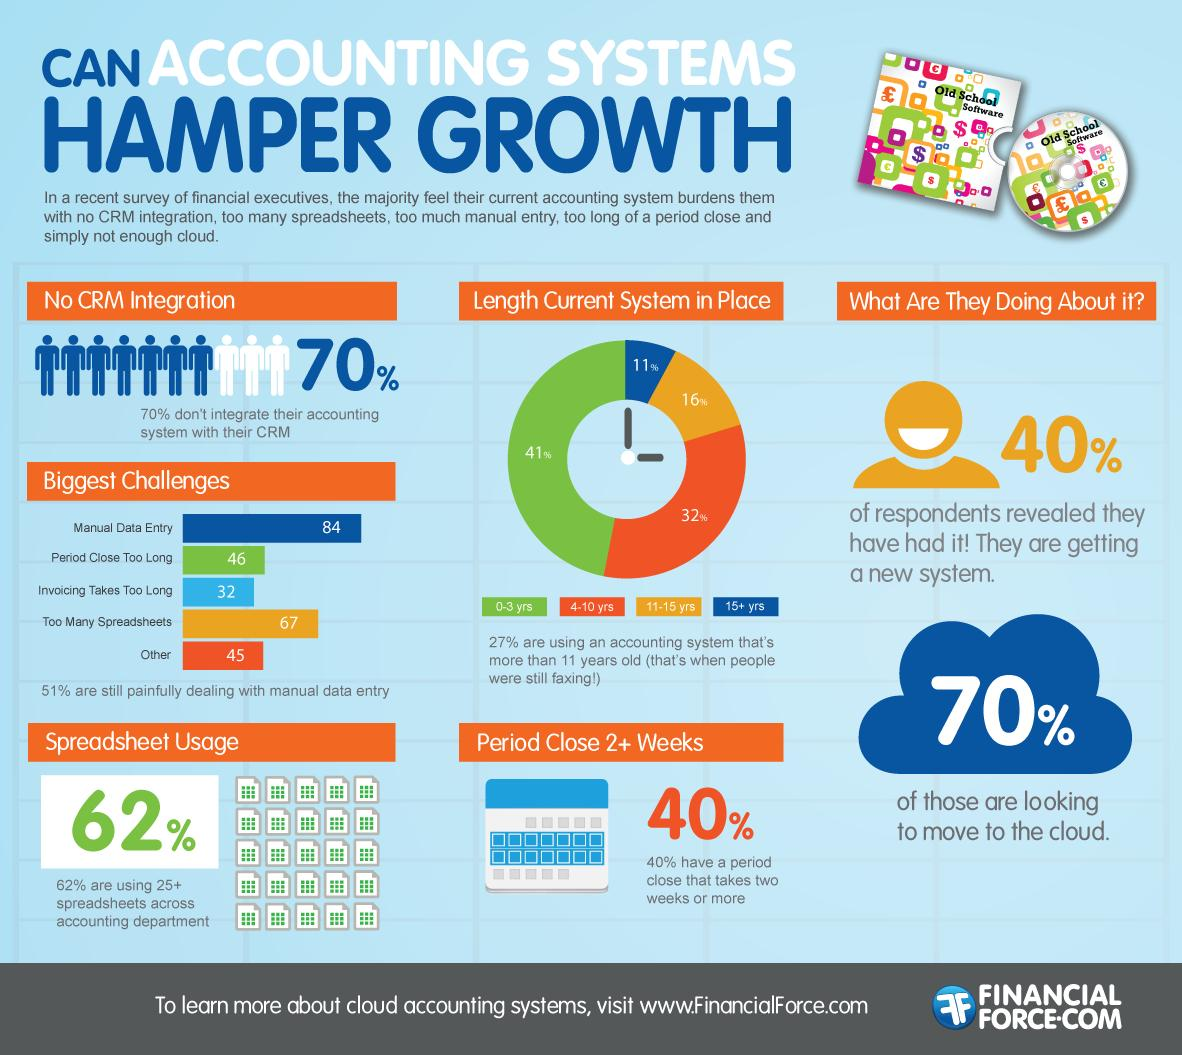Give some essential details in this illustration. Approximately 30% of people integrate their accounting system with their CRM. According to the given information, approximately 30% of the respondents are not moving to the cloud. A majority of respondents, 60%, are not getting a new system. According to our data, 32% of the respondents are using systems that are 4-10 years old. In second place, the biggest challenge is the use of too many spreadsheets, which can lead to errors, inefficiency, and difficulty in analyzing data. 